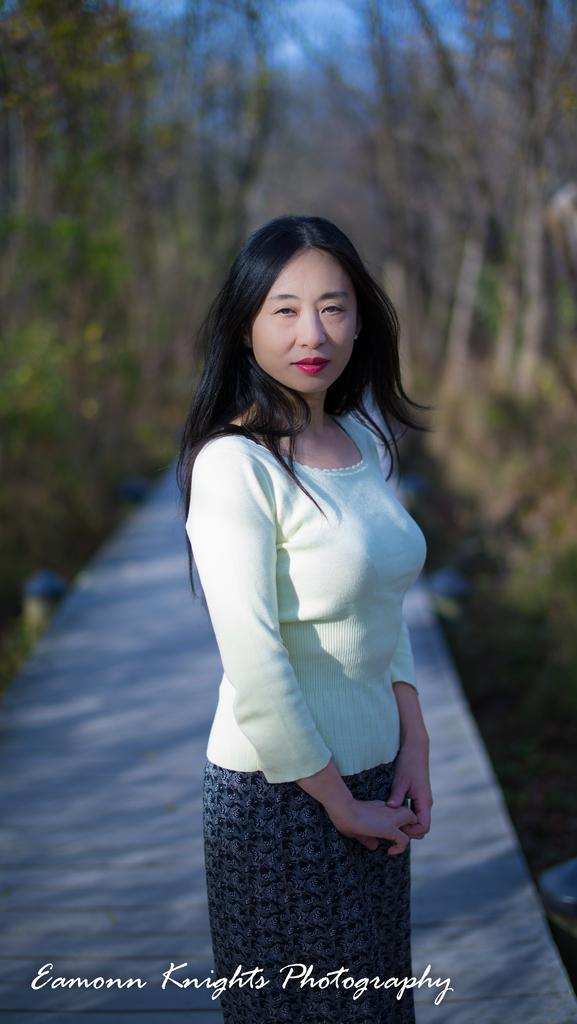Who is the main subject in the image? There is a lady standing in the center of the image. What can be seen in the background of the image? There are trees in the background of the image. What type of structure is visible at the bottom of the image? There is a bridge at the bottom of the image. What type of cracker is being used to cross the stream in the image? There is no stream or cracker present in the image. 